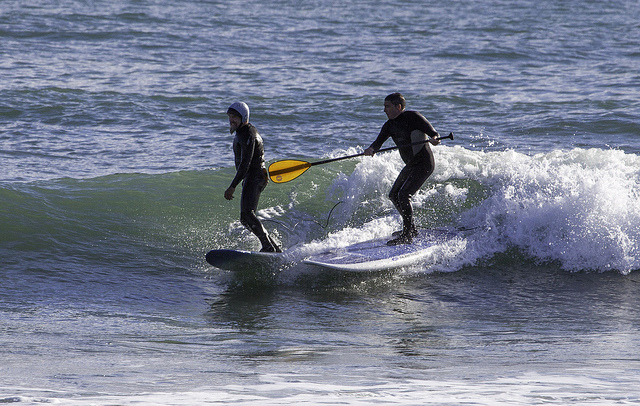<image>What gender are the people in the photo? I am not sure about the gender of the people in the photo, it could be both male and female. What gender are the people in the photo? I don't know the gender of the people in the photo. Some of them can be male and some can be female. 